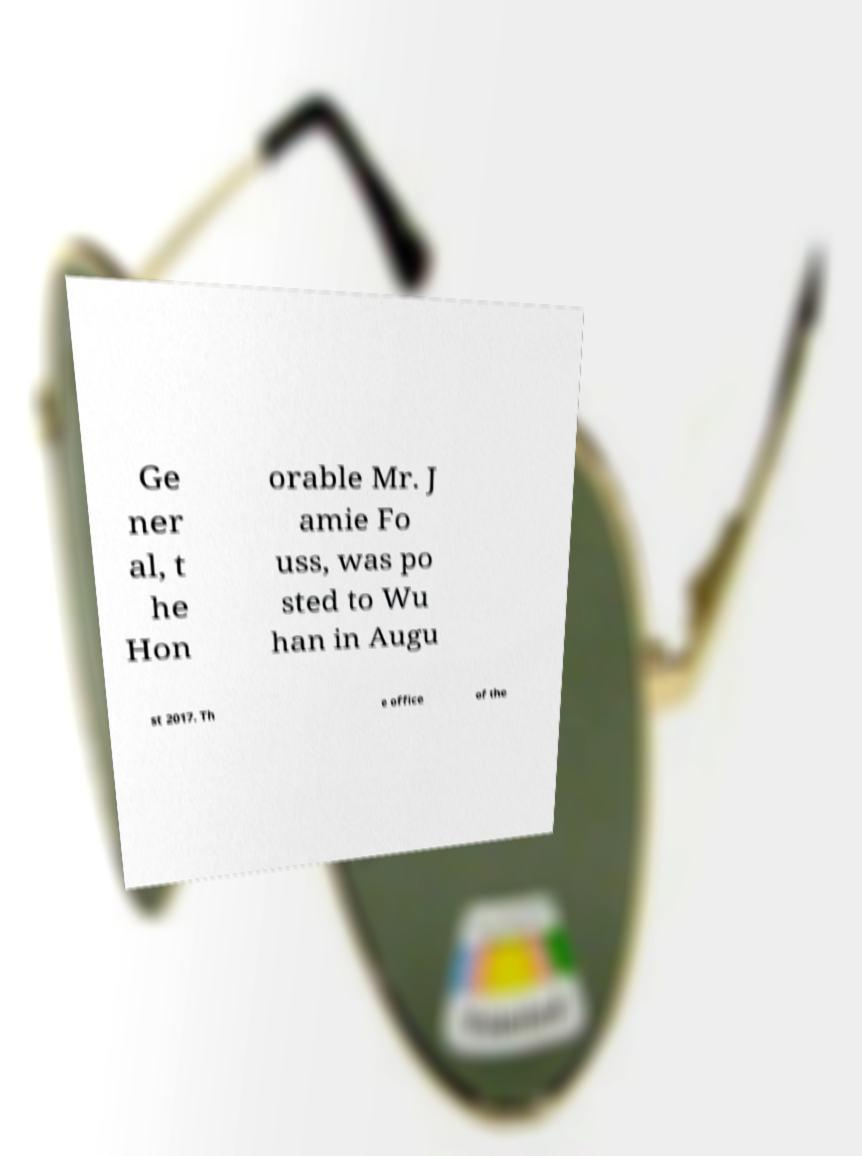Can you read and provide the text displayed in the image?This photo seems to have some interesting text. Can you extract and type it out for me? Ge ner al, t he Hon orable Mr. J amie Fo uss, was po sted to Wu han in Augu st 2017. Th e office of the 